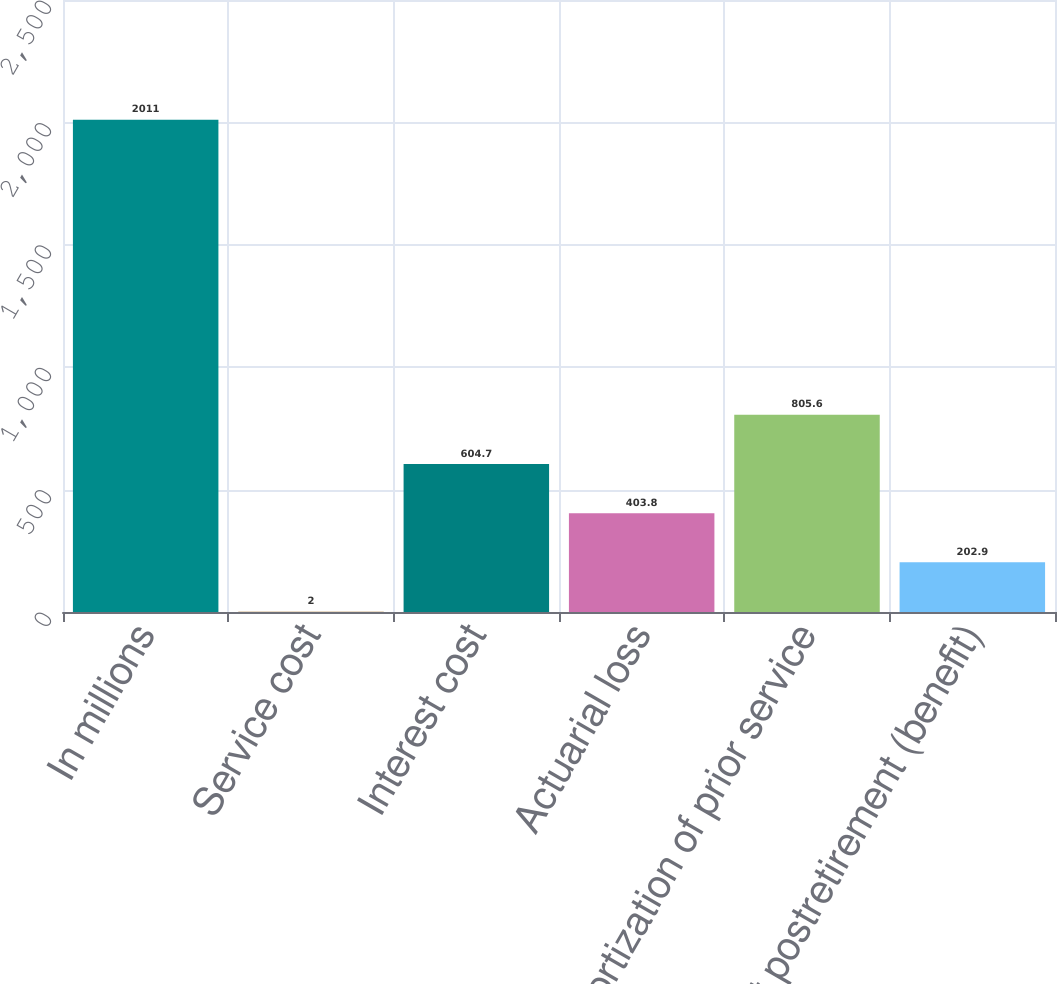<chart> <loc_0><loc_0><loc_500><loc_500><bar_chart><fcel>In millions<fcel>Service cost<fcel>Interest cost<fcel>Actuarial loss<fcel>Amortization of prior service<fcel>Net postretirement (benefit)<nl><fcel>2011<fcel>2<fcel>604.7<fcel>403.8<fcel>805.6<fcel>202.9<nl></chart> 